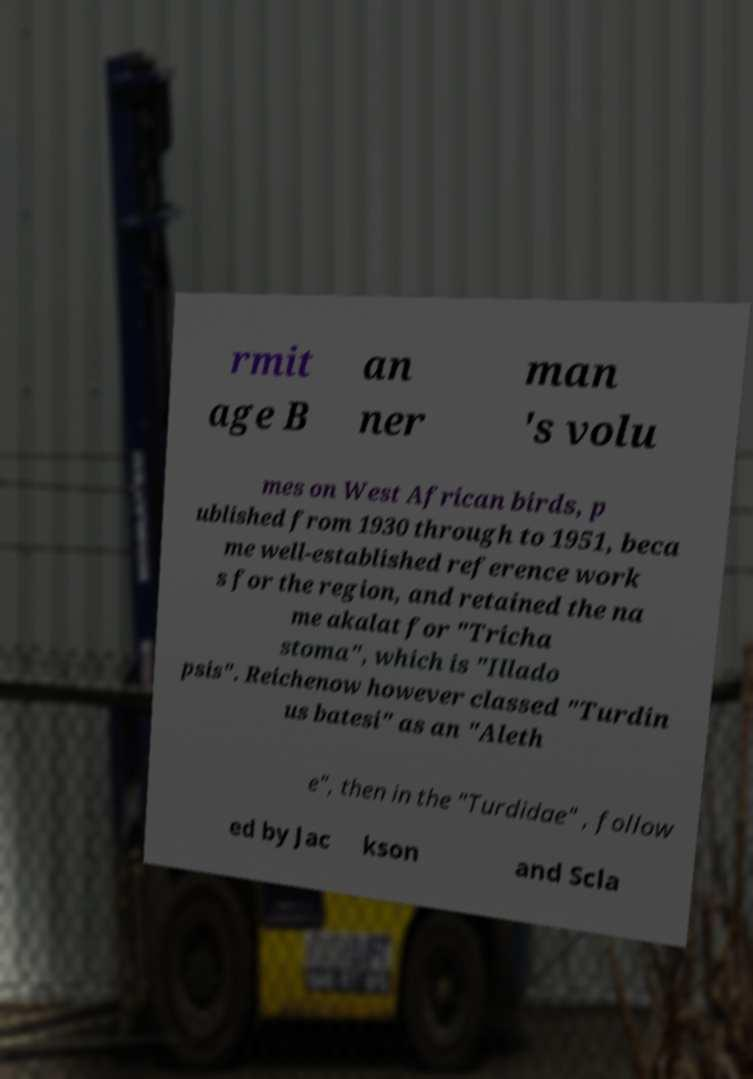There's text embedded in this image that I need extracted. Can you transcribe it verbatim? rmit age B an ner man 's volu mes on West African birds, p ublished from 1930 through to 1951, beca me well-established reference work s for the region, and retained the na me akalat for "Tricha stoma", which is "Illado psis". Reichenow however classed "Turdin us batesi" as an "Aleth e", then in the "Turdidae" , follow ed by Jac kson and Scla 